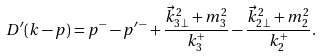<formula> <loc_0><loc_0><loc_500><loc_500>D ^ { \prime } ( k - p ) = p ^ { - } - p ^ { \prime \, - } + \frac { \vec { k } ^ { 2 } _ { 3 \, \perp } + m ^ { 2 } _ { 3 } } { k ^ { + } _ { 3 } } - \frac { \vec { k } ^ { 2 } _ { 2 \, \perp } + m ^ { 2 } _ { 2 } } { k ^ { + } _ { 2 } } .</formula> 